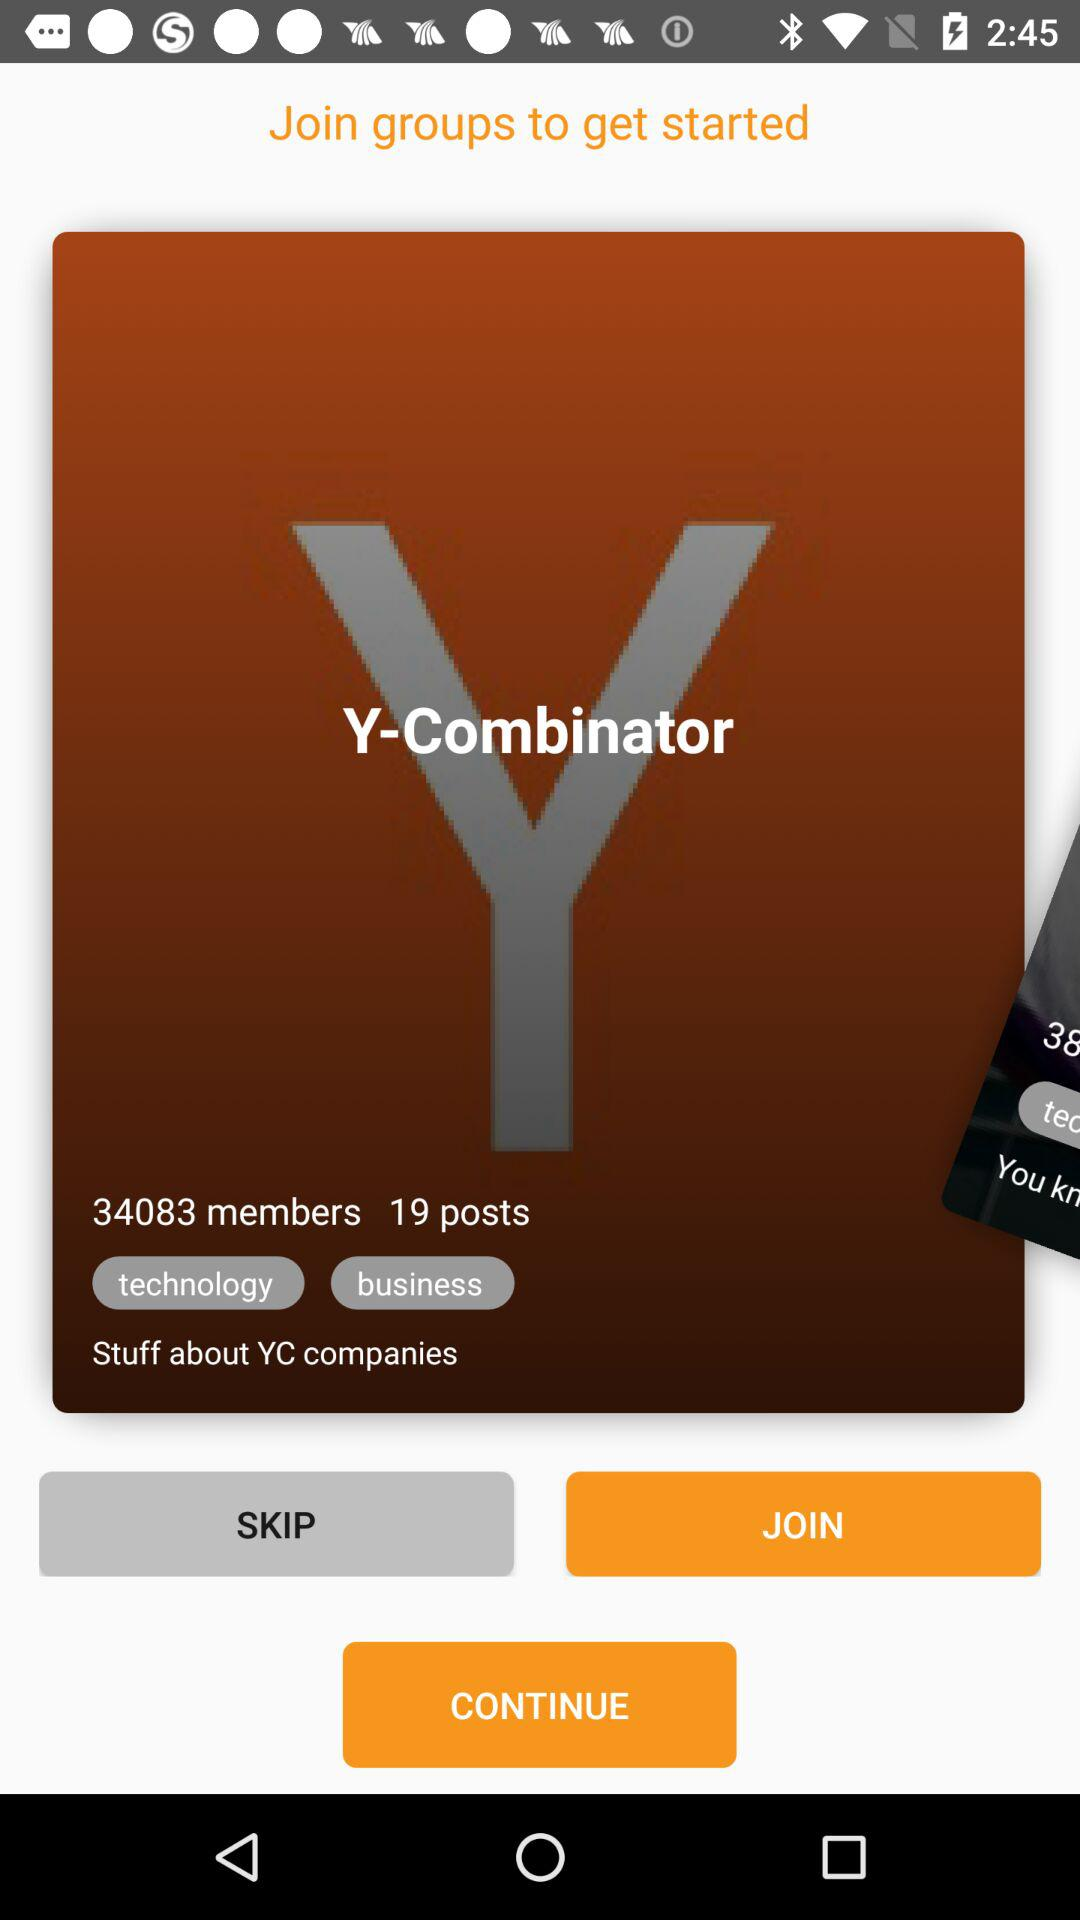How many posts are showing? There are 19 posts showing. 